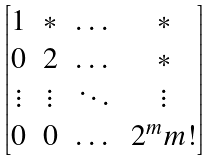<formula> <loc_0><loc_0><loc_500><loc_500>\begin{bmatrix} 1 & * & \dots & * \\ 0 & 2 & \dots & * \\ \vdots & \vdots & \ddots & \vdots \\ 0 & 0 & \dots & 2 ^ { m } m ! \end{bmatrix}</formula> 